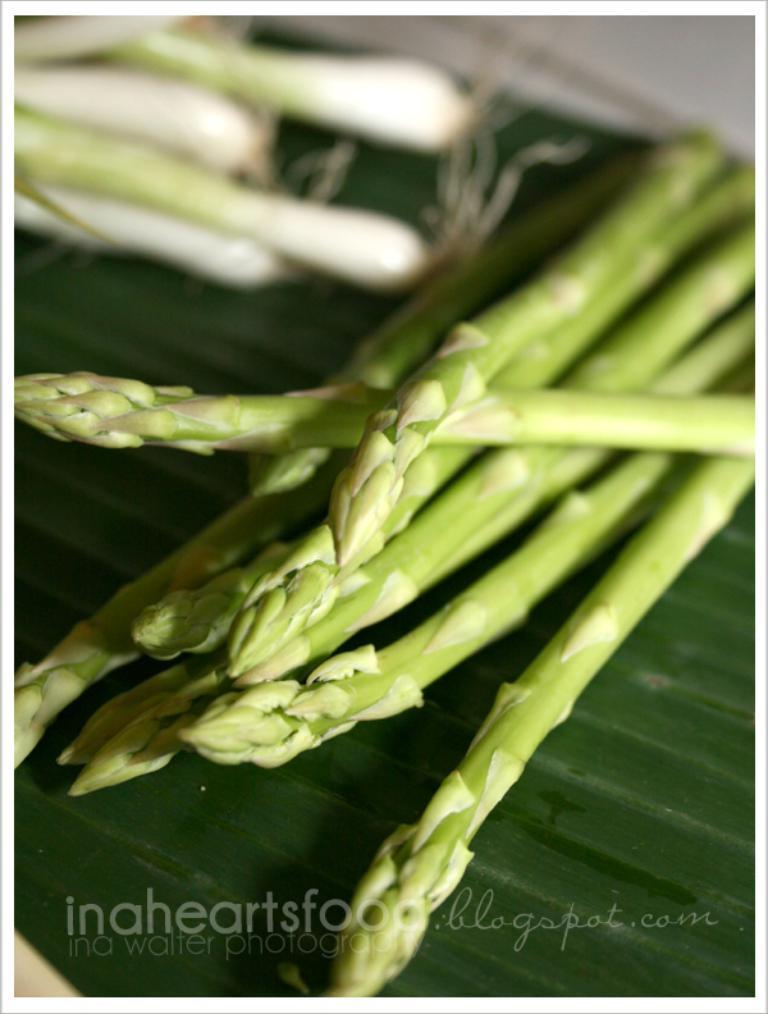How would you summarize this image in a sentence or two? In this image I can see number of green colour things in the front. On the bottom side of this image I can see a watermark. 